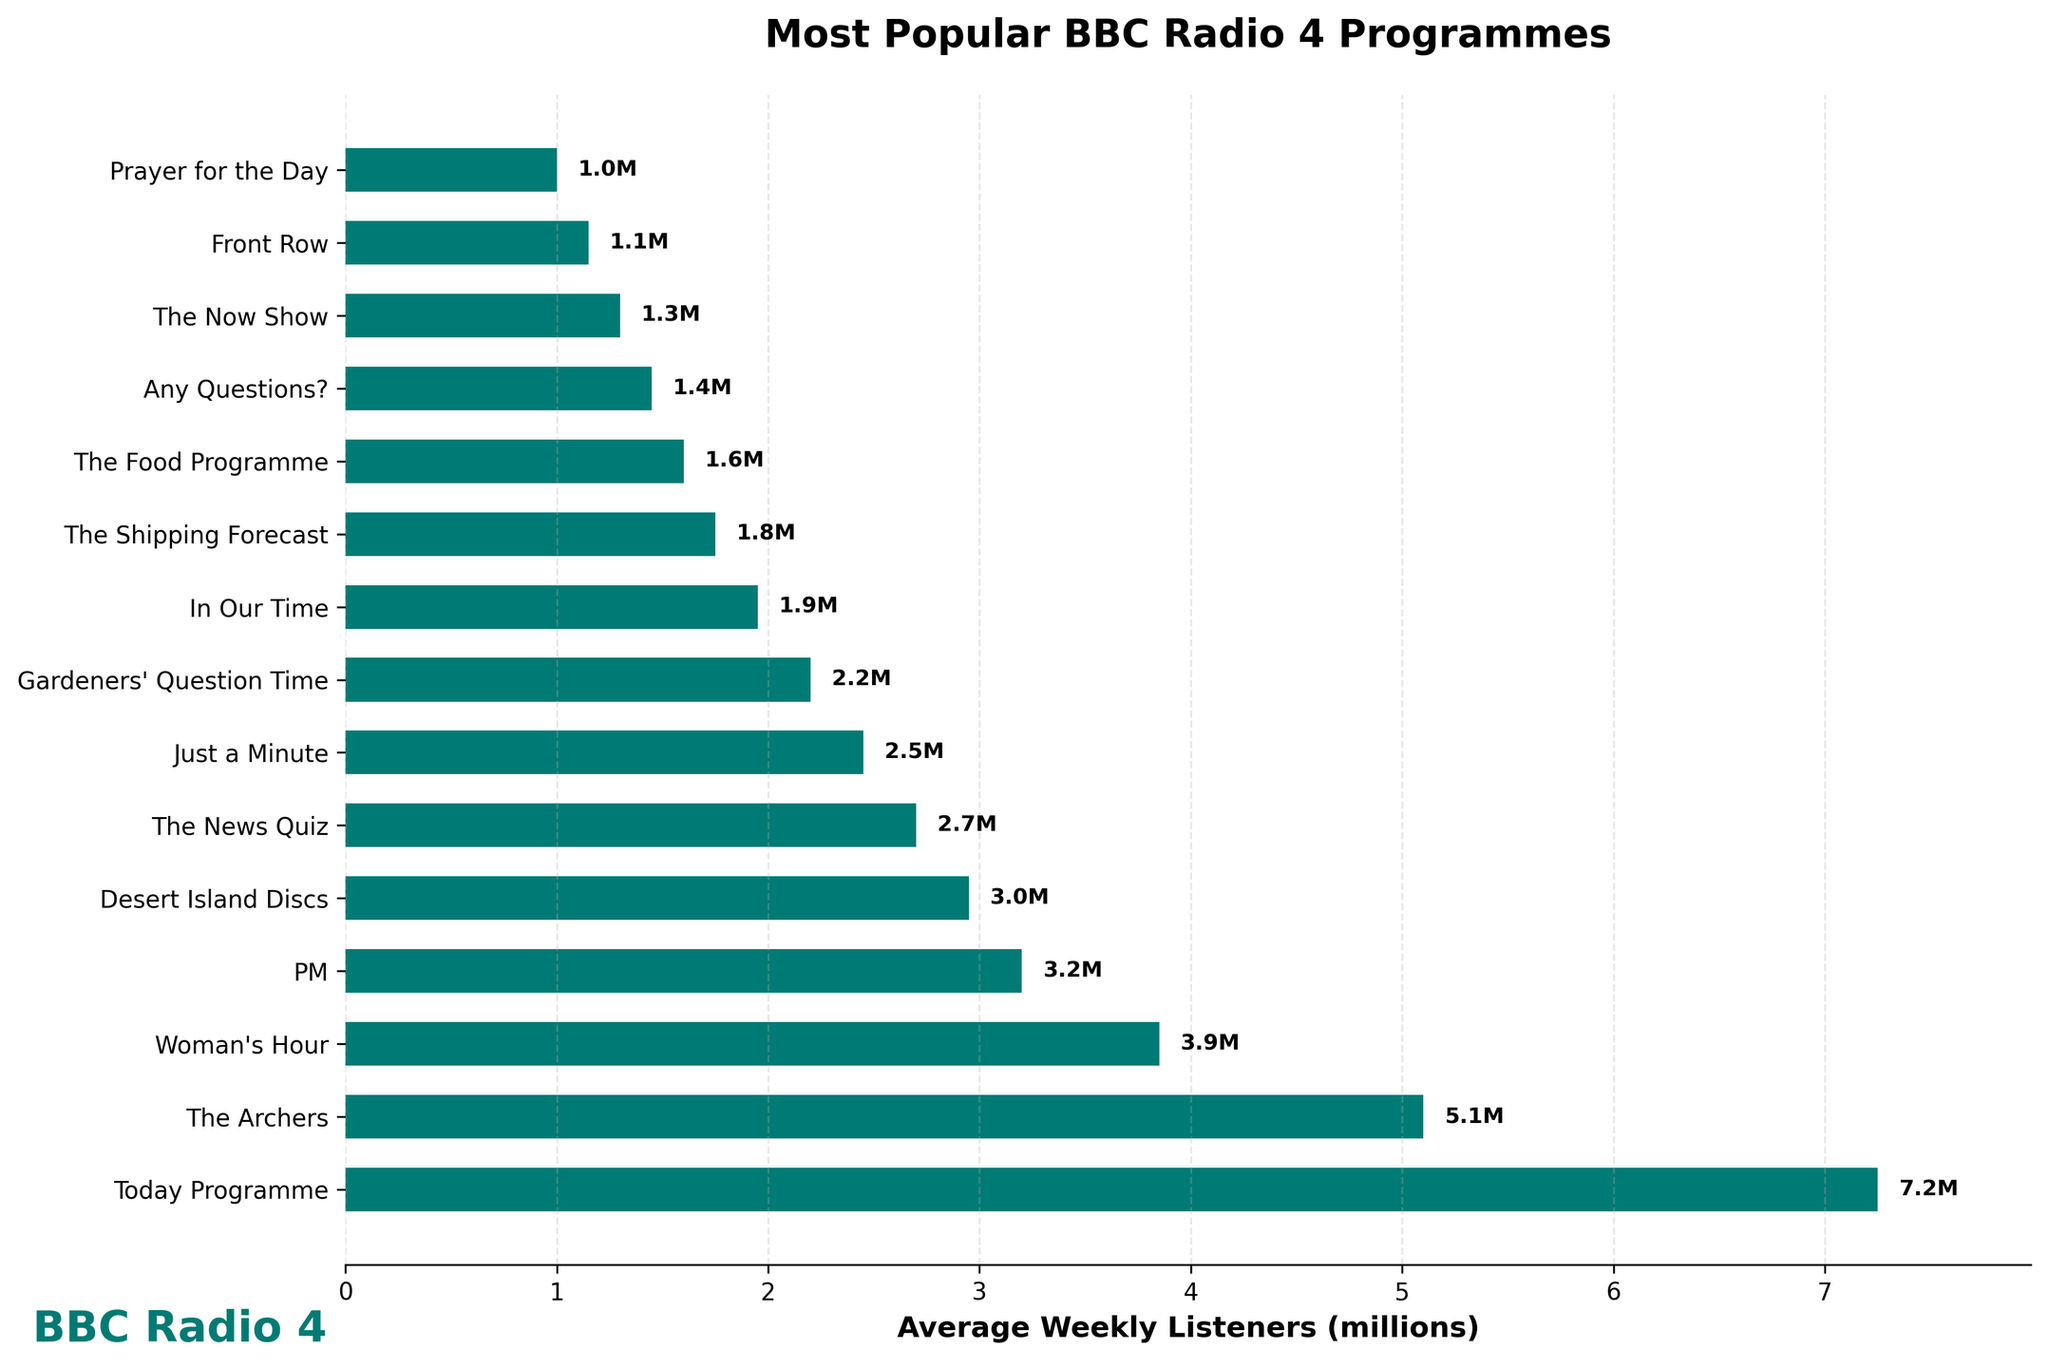What's the programme with the highest average weekly listeners? The programme with the longest bar corresponds to the Today Programme. A horizontal bar chart makes it easy to identify this as the bar extends the furthest to the right.
Answer: Today Programme What's the difference in average weekly listeners between The Archers and Desert Island Discs? First, note the average weekly listeners for The Archers (5.1 million) and Desert Island Discs (2.95 million). Calculate the difference: 5.1 - 2.95 = 2.15 million.
Answer: 2.15 million Which programme has fewer average weekly listeners: In Our Time or The Now Show? Compare the lengths of the bars for In Our Time (1.95 million) and The Now Show (1.3 million). The Now Show has a shorter bar, indicating fewer listeners.
Answer: The Now Show What is the combined average weekly listeners for PM and Woman's Hour? Add the average weekly listeners for PM (3.2 million) and Woman's Hour (3.85 million): 3.2 + 3.85 = 7.05 million.
Answer: 7.05 million Which programme has the closest average weekly listeners to 2 million? Look for bars around the 2 million mark. Gardeners' Question Time has 2.2 million listeners, which is closest to 2 million compared to the other values.
Answer: Gardeners' Question Time How many programmes have an average weekly listenership greater than 3 million? Count the number of bars extending beyond the 3 million mark. The programmes are Today Programme, The Archers, Woman's Hour, and PM. There are 4 such programmes.
Answer: 4 Which programme has the smallest number of average weekly listeners? Identify the shortest bar in the plot which corresponds to Prayer for the Day with 1 million listeners.
Answer: Prayer for the Day What is the sum of the average weekly listeners for the top 3 most popular programmes? The top three programs are Today Programme (7.25 million), The Archers (5.1 million), and Woman's Hour (3.85 million). Sum them: 7.25 + 5.1 + 3.85 = 16.2 million.
Answer: 16.2 million By how much does the average weekly listenership of The News Quiz differ from that of Just a Minute? Compare The News Quiz (2.7 million) and Just a Minute (2.45 million). The difference is 2.7 - 2.45 = 0.25 million.
Answer: 0.25 million How many programmes have average weekly listeners between 1 million and 3 million? Count the number of bars that fall within the range 1 million to 3 million. The programmes are Desert Island Discs, The News Quiz, Just a Minute, Gardeners' Question Time, In Our Time, The Shipping Forecast, and The Food Programme, totaling 7.
Answer: 7 